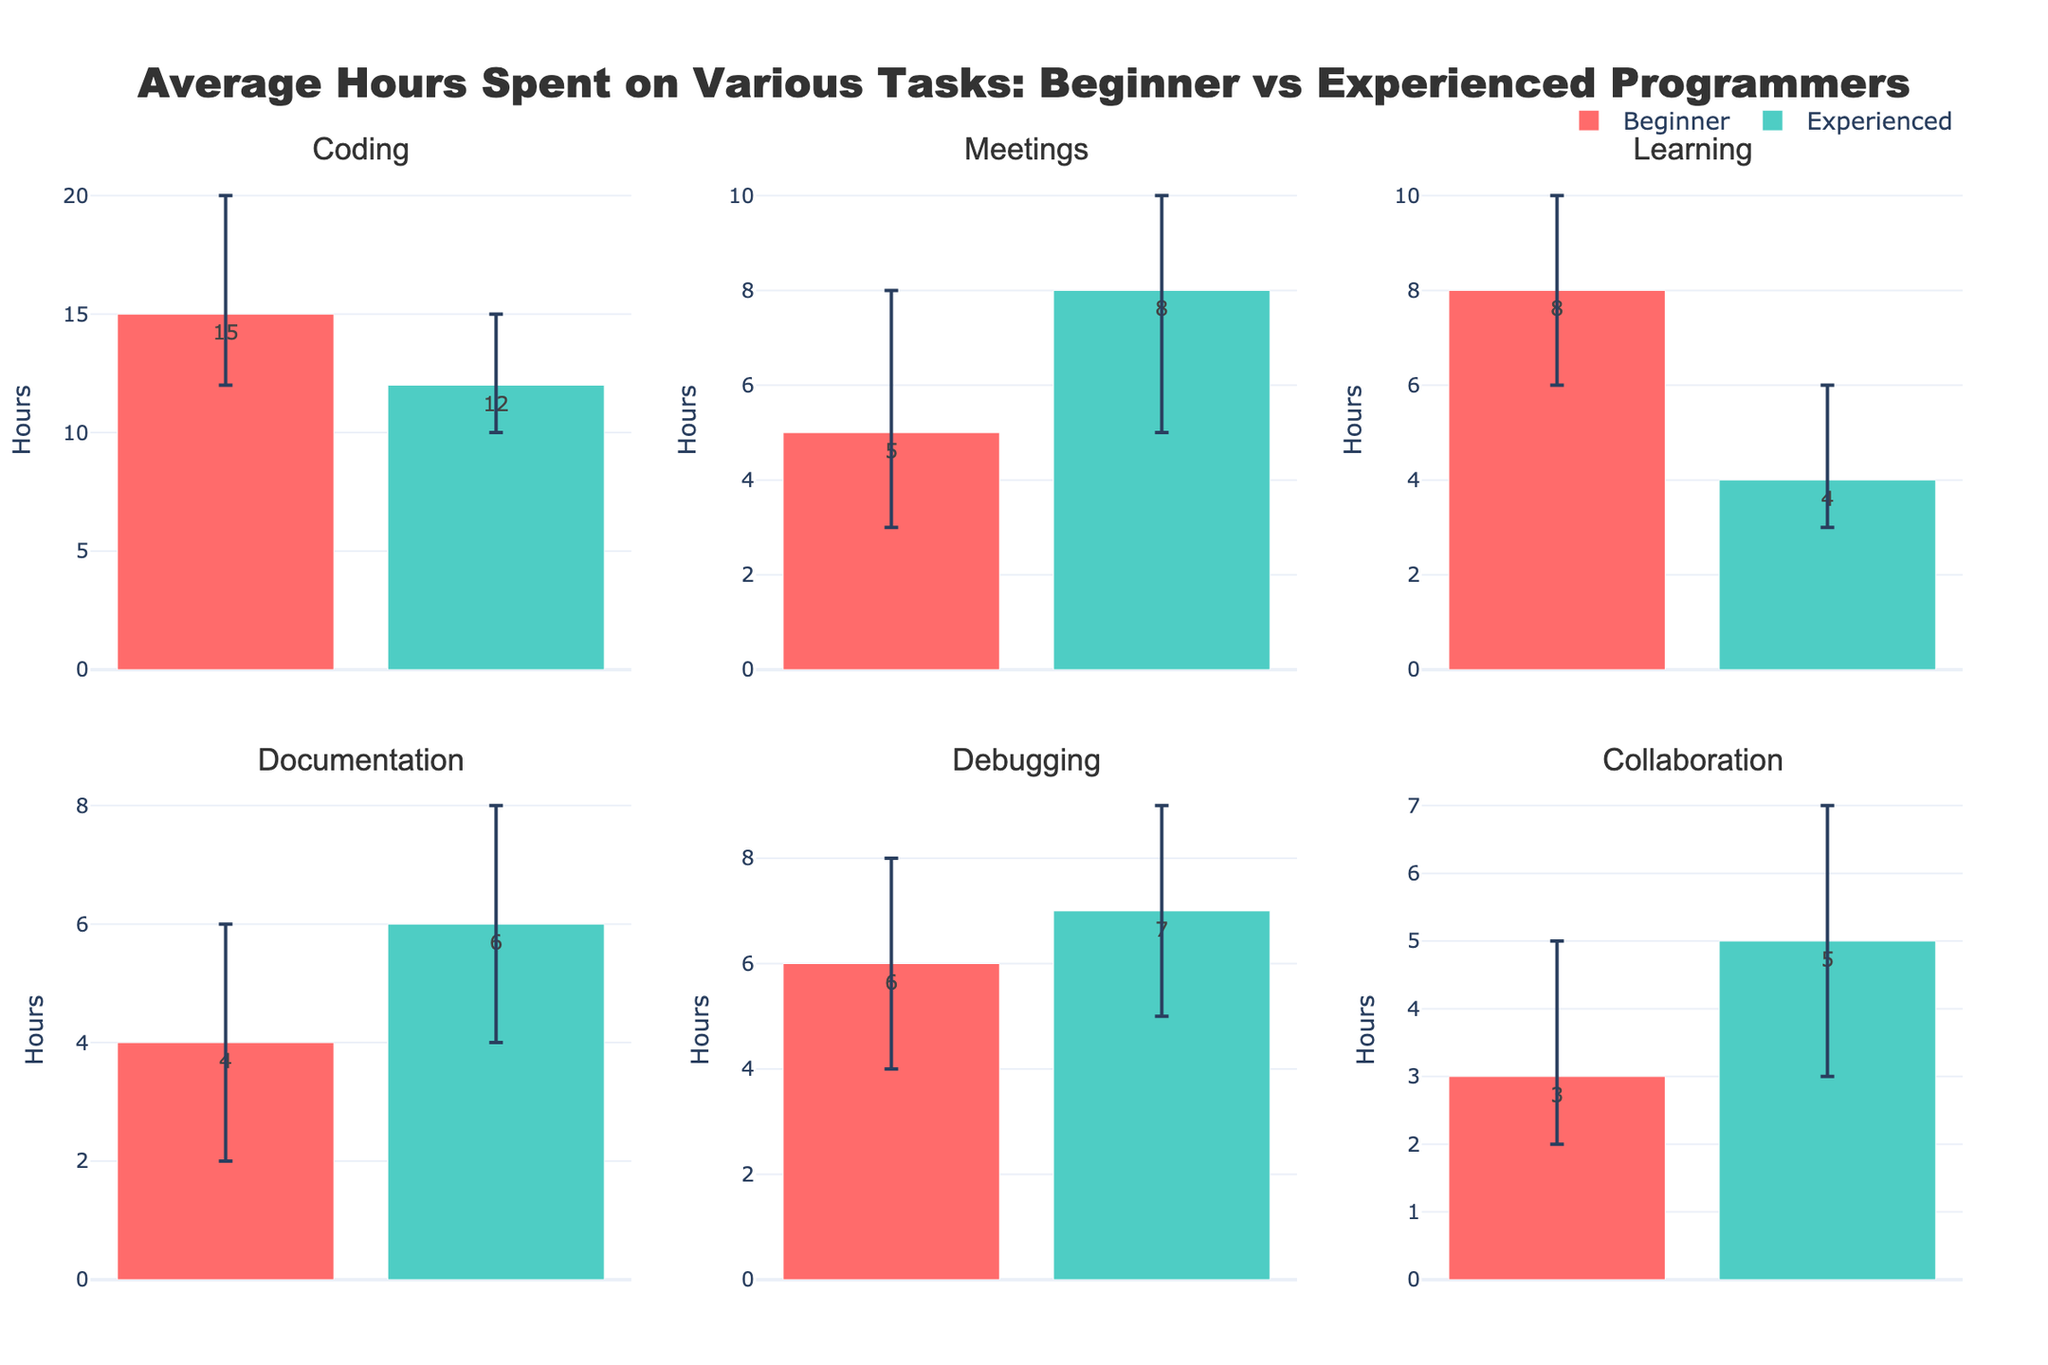What's the average number of hours beginner programmers spend coding? According to the data displayed in the figure, the average number of hours that beginner programmers spend coding is given directly by the bar above the "Beginner" category for the "Coding" task type.
Answer: 15 Which group spends more time in meetings, beginners or experienced programmers? To determine which group spends more time in meetings, compare the heights of the bars under the "Meetings" subplot for both beginners and experienced programmers. The bar for experienced programmers is taller.
Answer: Experienced What's the difference in average learning hours between beginners and experienced programmers? Look at the subplot for "Learning" tasks. Find the heights of the bars representing beginners (8 hours) and experienced (4 hours) programmers. Subtract the average hours of experienced programmers from that of beginners. 8 - 4 = 4
Answer: 4 In which task type do beginners spend the least amount of time on average? Check the subplots and compare the heights of the bars associated with beginners for each task type. The shortest bar corresponds to "Collaboration" with 3 hours.
Answer: Collaboration What's the range of hours worked on debugging by experienced programmers? To find the range, take the maximum and minimum values indicated by the error bars for "Debugging" under experienced programmers. The range is from 9 hours to 5 hours.
Answer: 4 (9 - 5) How much more time do experienced programmers spend in documentation compared to beginners? In the "Documentation" subplot, observe the bars for both groups. Experienced programmers average 6 hours, while beginners average 4 hours. Calculate the difference: 6 - 4 = 2
Answer: 2 Do beginners or experienced programmers have a larger error range for coding hours? Analyze the error bars in the "Coding" subplot: beginners have an error range from 20 to 12 (8 hours), and experienced programmers from 15 to 10 (5 hours). The error range for beginners is larger.
Answer: Beginners Is the error range for meetings symmetrical for experienced programmers? Look at the error bar for "Meetings" under experienced programmers. The upper bound is 10 hours, the lower is 5 hours, and the average is 8 hours, forming an asymmetric range (2 hours above and 3 hours below the average).
Answer: No What is the average number of hours spent on collaboration by experienced programmers? The average number of hours is represented by the height of the bar above the "Experienced" category in the "Collaboration" subplot.
Answer: 5 